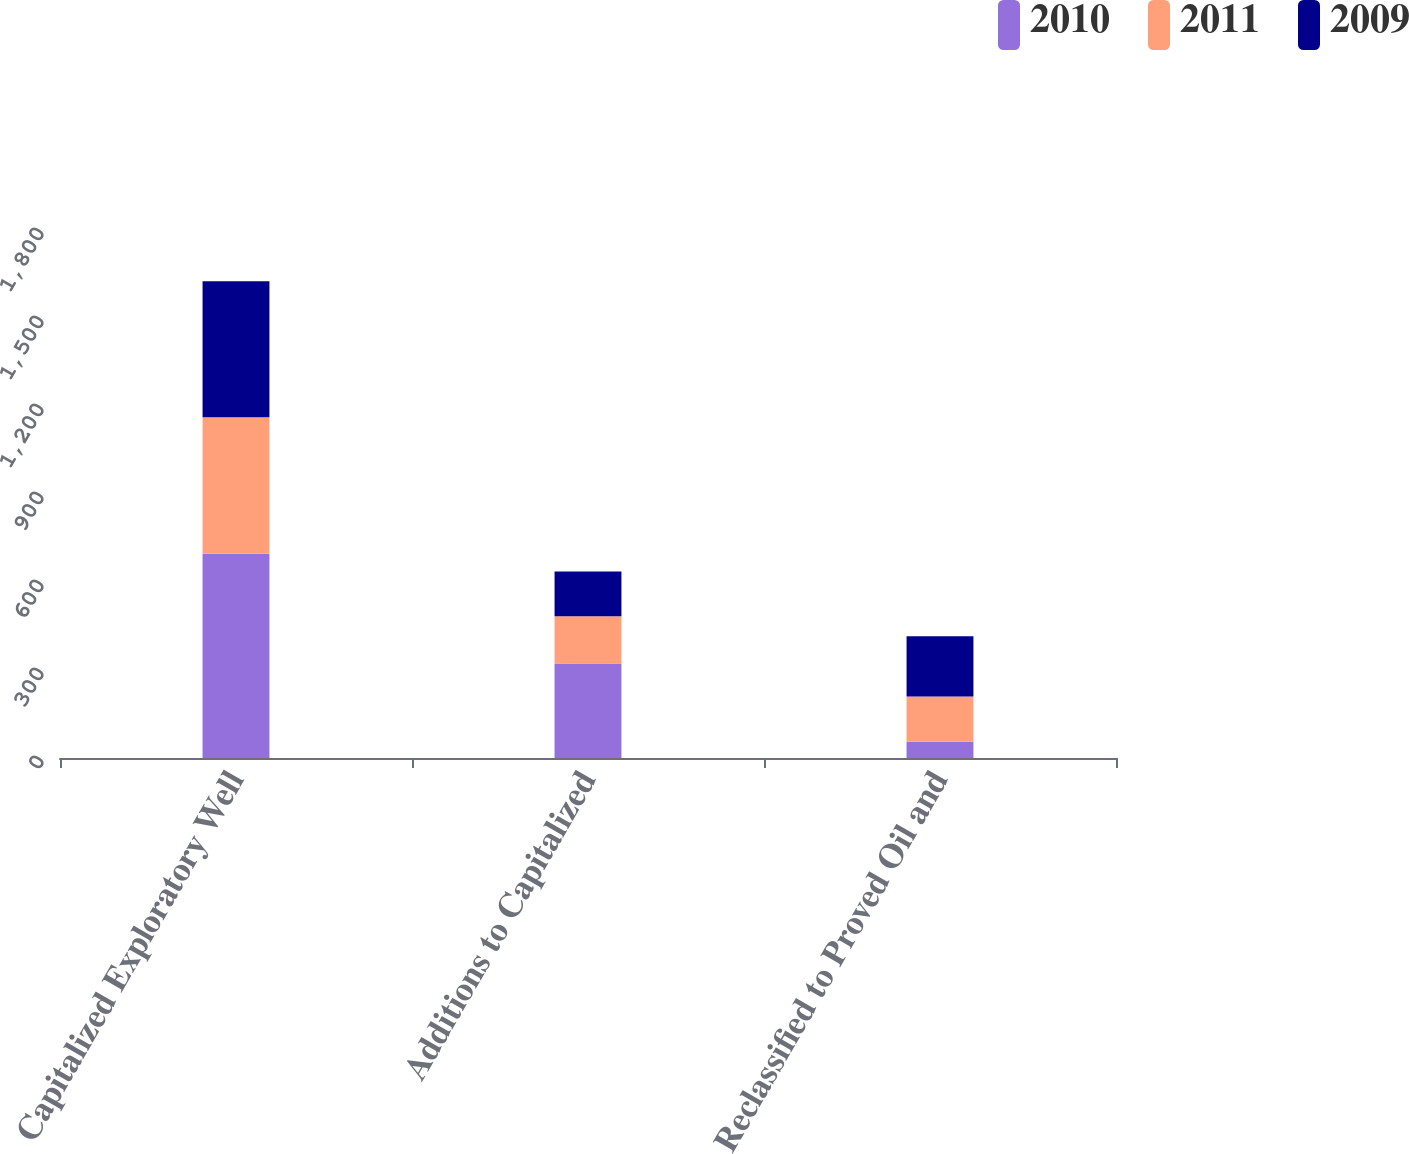Convert chart to OTSL. <chart><loc_0><loc_0><loc_500><loc_500><stacked_bar_chart><ecel><fcel>Capitalized Exploratory Well<fcel>Additions to Capitalized<fcel>Reclassified to Proved Oil and<nl><fcel>2010<fcel>696<fcel>322<fcel>55<nl><fcel>2011<fcel>466<fcel>161<fcel>155<nl><fcel>2009<fcel>463<fcel>153<fcel>205<nl></chart> 